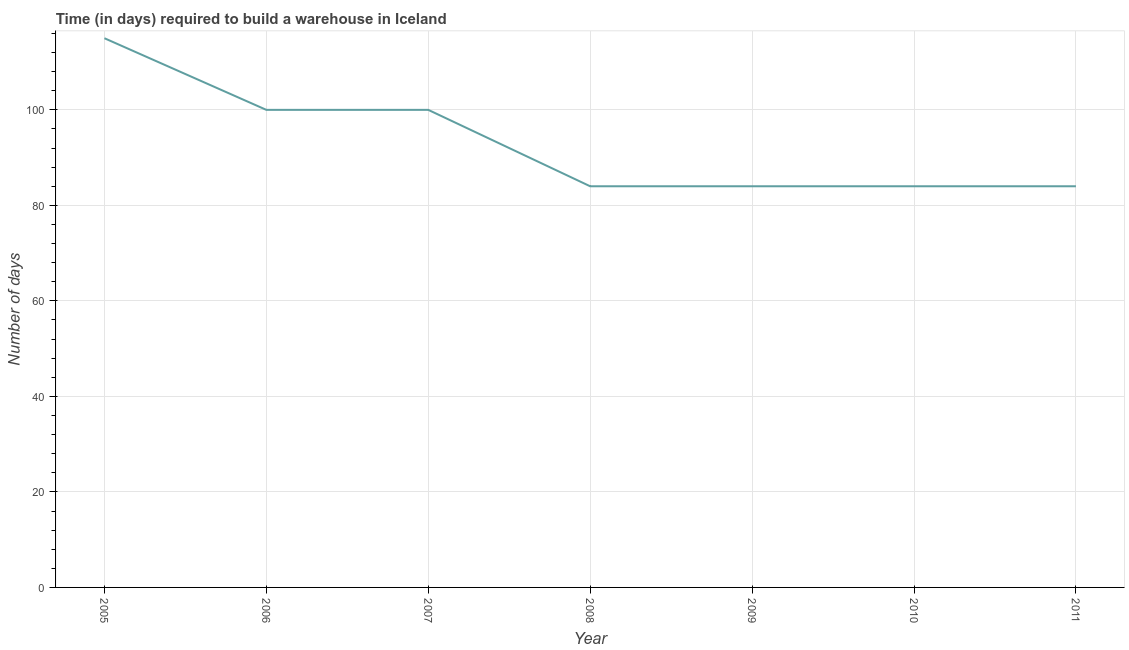What is the time required to build a warehouse in 2007?
Provide a short and direct response. 100. Across all years, what is the maximum time required to build a warehouse?
Your answer should be very brief. 115. Across all years, what is the minimum time required to build a warehouse?
Provide a short and direct response. 84. In which year was the time required to build a warehouse minimum?
Provide a short and direct response. 2008. What is the sum of the time required to build a warehouse?
Offer a terse response. 651. What is the difference between the time required to build a warehouse in 2005 and 2011?
Offer a terse response. 31. What is the average time required to build a warehouse per year?
Offer a very short reply. 93. In how many years, is the time required to build a warehouse greater than 36 days?
Offer a terse response. 7. What is the ratio of the time required to build a warehouse in 2006 to that in 2008?
Your answer should be very brief. 1.19. Is the time required to build a warehouse in 2007 less than that in 2009?
Provide a short and direct response. No. What is the difference between the highest and the lowest time required to build a warehouse?
Give a very brief answer. 31. Does the time required to build a warehouse monotonically increase over the years?
Your answer should be very brief. No. How many lines are there?
Provide a succinct answer. 1. How many years are there in the graph?
Keep it short and to the point. 7. What is the difference between two consecutive major ticks on the Y-axis?
Ensure brevity in your answer.  20. Does the graph contain any zero values?
Your response must be concise. No. Does the graph contain grids?
Your response must be concise. Yes. What is the title of the graph?
Make the answer very short. Time (in days) required to build a warehouse in Iceland. What is the label or title of the X-axis?
Provide a succinct answer. Year. What is the label or title of the Y-axis?
Your answer should be very brief. Number of days. What is the Number of days in 2005?
Keep it short and to the point. 115. What is the Number of days in 2007?
Offer a terse response. 100. What is the Number of days of 2008?
Your answer should be very brief. 84. What is the Number of days in 2009?
Offer a terse response. 84. What is the Number of days in 2010?
Your response must be concise. 84. What is the difference between the Number of days in 2005 and 2007?
Ensure brevity in your answer.  15. What is the difference between the Number of days in 2005 and 2009?
Keep it short and to the point. 31. What is the difference between the Number of days in 2005 and 2010?
Provide a short and direct response. 31. What is the difference between the Number of days in 2005 and 2011?
Provide a succinct answer. 31. What is the difference between the Number of days in 2006 and 2007?
Give a very brief answer. 0. What is the difference between the Number of days in 2006 and 2009?
Offer a very short reply. 16. What is the difference between the Number of days in 2006 and 2010?
Provide a succinct answer. 16. What is the difference between the Number of days in 2007 and 2008?
Offer a terse response. 16. What is the difference between the Number of days in 2007 and 2011?
Your response must be concise. 16. What is the difference between the Number of days in 2008 and 2009?
Give a very brief answer. 0. What is the difference between the Number of days in 2008 and 2010?
Your answer should be compact. 0. What is the difference between the Number of days in 2008 and 2011?
Make the answer very short. 0. What is the ratio of the Number of days in 2005 to that in 2006?
Your answer should be compact. 1.15. What is the ratio of the Number of days in 2005 to that in 2007?
Offer a terse response. 1.15. What is the ratio of the Number of days in 2005 to that in 2008?
Give a very brief answer. 1.37. What is the ratio of the Number of days in 2005 to that in 2009?
Provide a short and direct response. 1.37. What is the ratio of the Number of days in 2005 to that in 2010?
Your answer should be very brief. 1.37. What is the ratio of the Number of days in 2005 to that in 2011?
Offer a very short reply. 1.37. What is the ratio of the Number of days in 2006 to that in 2007?
Make the answer very short. 1. What is the ratio of the Number of days in 2006 to that in 2008?
Provide a short and direct response. 1.19. What is the ratio of the Number of days in 2006 to that in 2009?
Give a very brief answer. 1.19. What is the ratio of the Number of days in 2006 to that in 2010?
Your answer should be very brief. 1.19. What is the ratio of the Number of days in 2006 to that in 2011?
Make the answer very short. 1.19. What is the ratio of the Number of days in 2007 to that in 2008?
Provide a short and direct response. 1.19. What is the ratio of the Number of days in 2007 to that in 2009?
Offer a terse response. 1.19. What is the ratio of the Number of days in 2007 to that in 2010?
Keep it short and to the point. 1.19. What is the ratio of the Number of days in 2007 to that in 2011?
Make the answer very short. 1.19. What is the ratio of the Number of days in 2008 to that in 2009?
Your answer should be very brief. 1. What is the ratio of the Number of days in 2008 to that in 2010?
Give a very brief answer. 1. What is the ratio of the Number of days in 2009 to that in 2010?
Keep it short and to the point. 1. What is the ratio of the Number of days in 2010 to that in 2011?
Give a very brief answer. 1. 